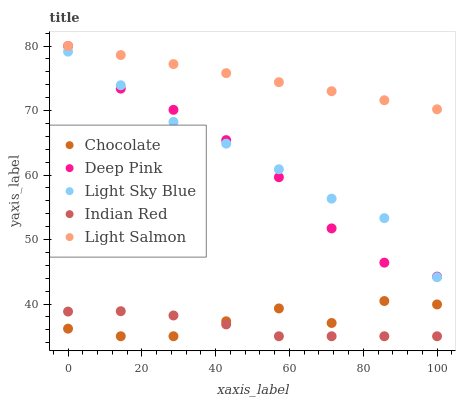Does Indian Red have the minimum area under the curve?
Answer yes or no. Yes. Does Light Salmon have the maximum area under the curve?
Answer yes or no. Yes. Does Deep Pink have the minimum area under the curve?
Answer yes or no. No. Does Deep Pink have the maximum area under the curve?
Answer yes or no. No. Is Light Salmon the smoothest?
Answer yes or no. Yes. Is Chocolate the roughest?
Answer yes or no. Yes. Is Deep Pink the smoothest?
Answer yes or no. No. Is Deep Pink the roughest?
Answer yes or no. No. Does Indian Red have the lowest value?
Answer yes or no. Yes. Does Deep Pink have the lowest value?
Answer yes or no. No. Does Deep Pink have the highest value?
Answer yes or no. Yes. Does Indian Red have the highest value?
Answer yes or no. No. Is Chocolate less than Light Salmon?
Answer yes or no. Yes. Is Deep Pink greater than Indian Red?
Answer yes or no. Yes. Does Light Sky Blue intersect Deep Pink?
Answer yes or no. Yes. Is Light Sky Blue less than Deep Pink?
Answer yes or no. No. Is Light Sky Blue greater than Deep Pink?
Answer yes or no. No. Does Chocolate intersect Light Salmon?
Answer yes or no. No. 